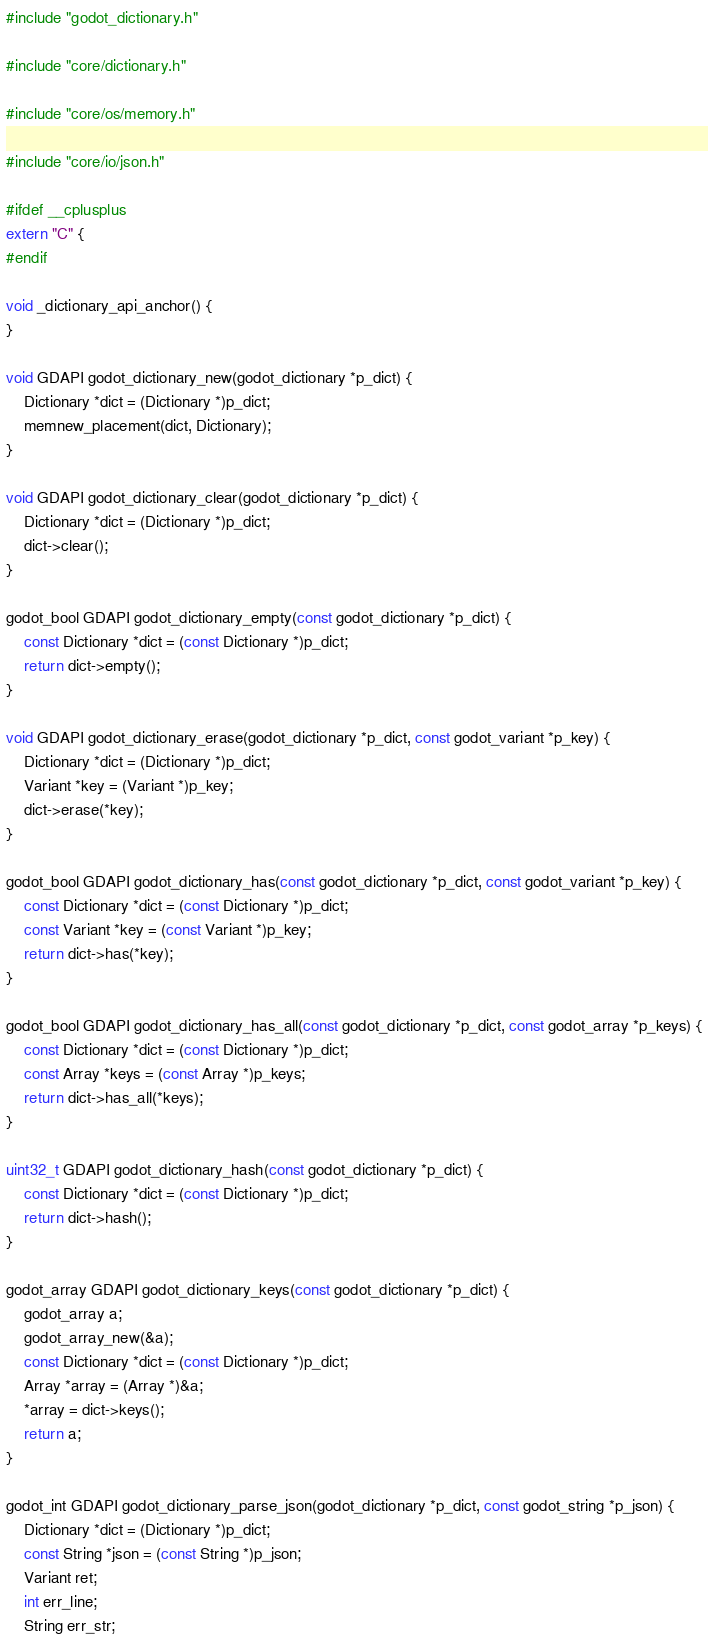Convert code to text. <code><loc_0><loc_0><loc_500><loc_500><_C++_>#include "godot_dictionary.h"

#include "core/dictionary.h"

#include "core/os/memory.h"

#include "core/io/json.h"

#ifdef __cplusplus
extern "C" {
#endif

void _dictionary_api_anchor() {
}

void GDAPI godot_dictionary_new(godot_dictionary *p_dict) {
	Dictionary *dict = (Dictionary *)p_dict;
	memnew_placement(dict, Dictionary);
}

void GDAPI godot_dictionary_clear(godot_dictionary *p_dict) {
	Dictionary *dict = (Dictionary *)p_dict;
	dict->clear();
}

godot_bool GDAPI godot_dictionary_empty(const godot_dictionary *p_dict) {
	const Dictionary *dict = (const Dictionary *)p_dict;
	return dict->empty();
}

void GDAPI godot_dictionary_erase(godot_dictionary *p_dict, const godot_variant *p_key) {
	Dictionary *dict = (Dictionary *)p_dict;
	Variant *key = (Variant *)p_key;
	dict->erase(*key);
}

godot_bool GDAPI godot_dictionary_has(const godot_dictionary *p_dict, const godot_variant *p_key) {
	const Dictionary *dict = (const Dictionary *)p_dict;
	const Variant *key = (const Variant *)p_key;
	return dict->has(*key);
}

godot_bool GDAPI godot_dictionary_has_all(const godot_dictionary *p_dict, const godot_array *p_keys) {
	const Dictionary *dict = (const Dictionary *)p_dict;
	const Array *keys = (const Array *)p_keys;
	return dict->has_all(*keys);
}

uint32_t GDAPI godot_dictionary_hash(const godot_dictionary *p_dict) {
	const Dictionary *dict = (const Dictionary *)p_dict;
	return dict->hash();
}

godot_array GDAPI godot_dictionary_keys(const godot_dictionary *p_dict) {
	godot_array a;
	godot_array_new(&a);
	const Dictionary *dict = (const Dictionary *)p_dict;
	Array *array = (Array *)&a;
	*array = dict->keys();
	return a;
}

godot_int GDAPI godot_dictionary_parse_json(godot_dictionary *p_dict, const godot_string *p_json) {
	Dictionary *dict = (Dictionary *)p_dict;
	const String *json = (const String *)p_json;
	Variant ret;
	int err_line;
	String err_str;</code> 